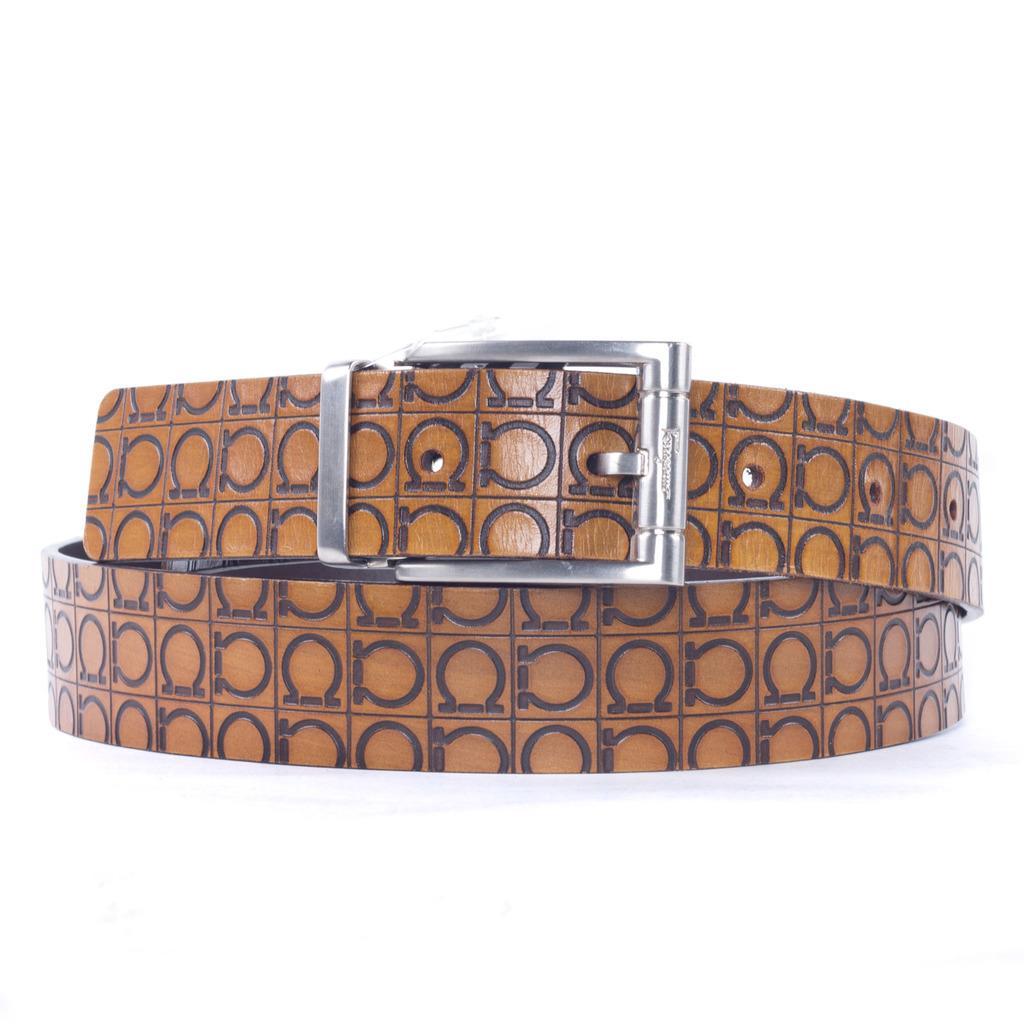Can you describe this image briefly? In the center of this picture we can see the belt and we can see the loop, buckle and the strap of the belt. The background of the image is white in color. 